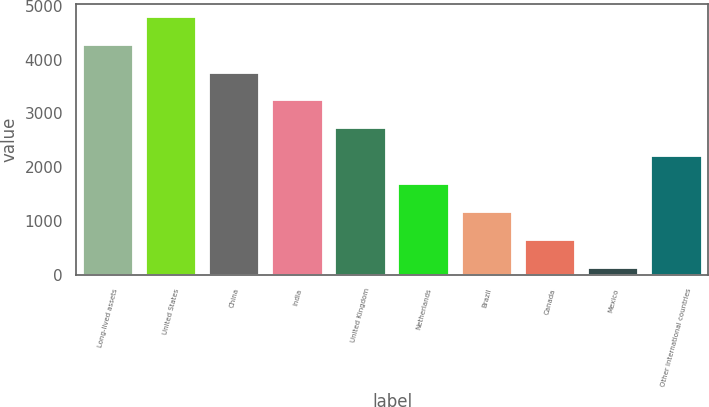<chart> <loc_0><loc_0><loc_500><loc_500><bar_chart><fcel>Long-lived assets<fcel>United States<fcel>China<fcel>India<fcel>United Kingdom<fcel>Netherlands<fcel>Brazil<fcel>Canada<fcel>Mexico<fcel>Other international countries<nl><fcel>4280.6<fcel>4799.3<fcel>3761.9<fcel>3243.2<fcel>2724.5<fcel>1687.1<fcel>1168.4<fcel>649.7<fcel>131<fcel>2205.8<nl></chart> 